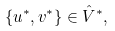Convert formula to latex. <formula><loc_0><loc_0><loc_500><loc_500>\{ u ^ { * } , v ^ { * } \} \in \hat { V } ^ { * } ,</formula> 